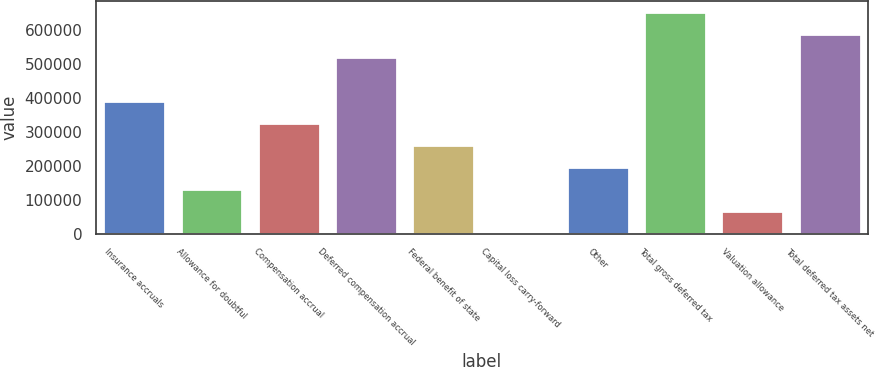<chart> <loc_0><loc_0><loc_500><loc_500><bar_chart><fcel>Insurance accruals<fcel>Allowance for doubtful<fcel>Compensation accrual<fcel>Deferred compensation accrual<fcel>Federal benefit of state<fcel>Capital loss carry-forward<fcel>Other<fcel>Total gross deferred tax<fcel>Valuation allowance<fcel>Total deferred tax assets net<nl><fcel>391645<fcel>131510<fcel>326612<fcel>521713<fcel>261578<fcel>1443<fcel>196544<fcel>651780<fcel>66476.7<fcel>586746<nl></chart> 